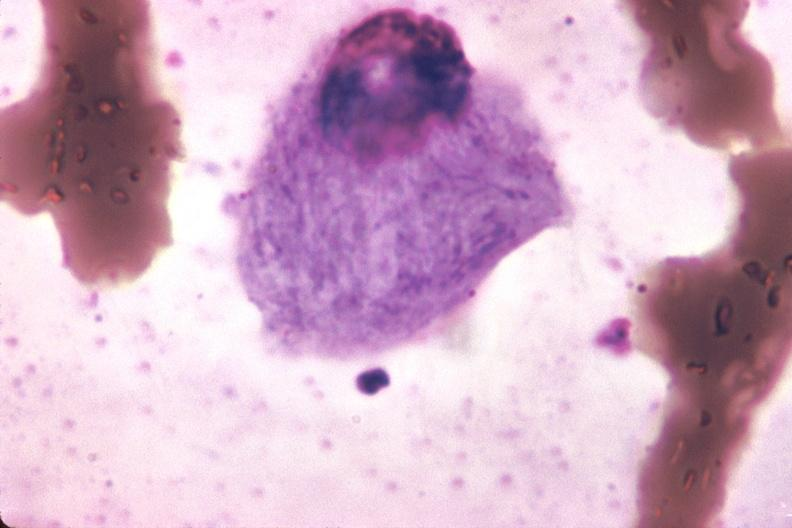s gaucher cell present?
Answer the question using a single word or phrase. Yes 